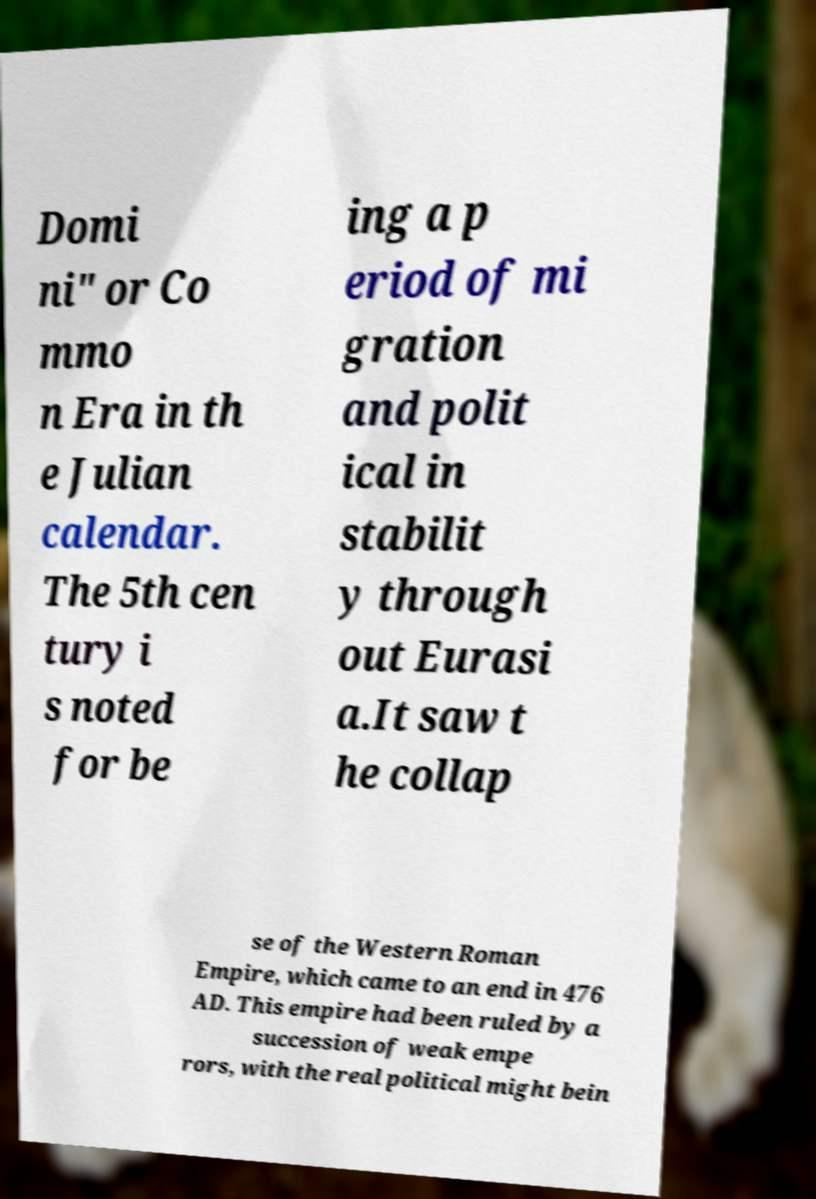Could you extract and type out the text from this image? Domi ni" or Co mmo n Era in th e Julian calendar. The 5th cen tury i s noted for be ing a p eriod of mi gration and polit ical in stabilit y through out Eurasi a.It saw t he collap se of the Western Roman Empire, which came to an end in 476 AD. This empire had been ruled by a succession of weak empe rors, with the real political might bein 